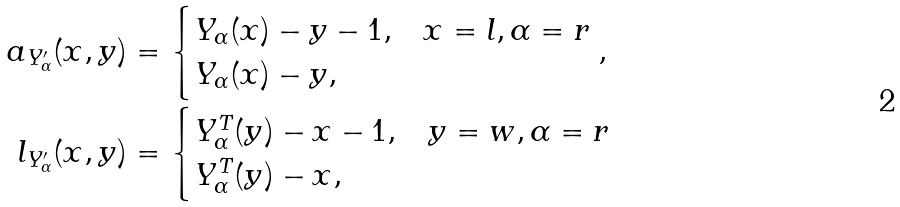Convert formula to latex. <formula><loc_0><loc_0><loc_500><loc_500>a _ { Y ^ { \prime } _ { \alpha } } ( x , y ) & = \begin{cases} Y _ { \alpha } ( x ) - y - 1 , & x = l , \alpha = r \\ Y _ { \alpha } ( x ) - y , & \end{cases} , \\ l _ { Y ^ { \prime } _ { \alpha } } ( x , y ) & = \begin{cases} Y _ { \alpha } ^ { T } ( y ) - x - 1 , & y = w , \alpha = r \\ Y _ { \alpha } ^ { T } ( y ) - x , & \end{cases}</formula> 